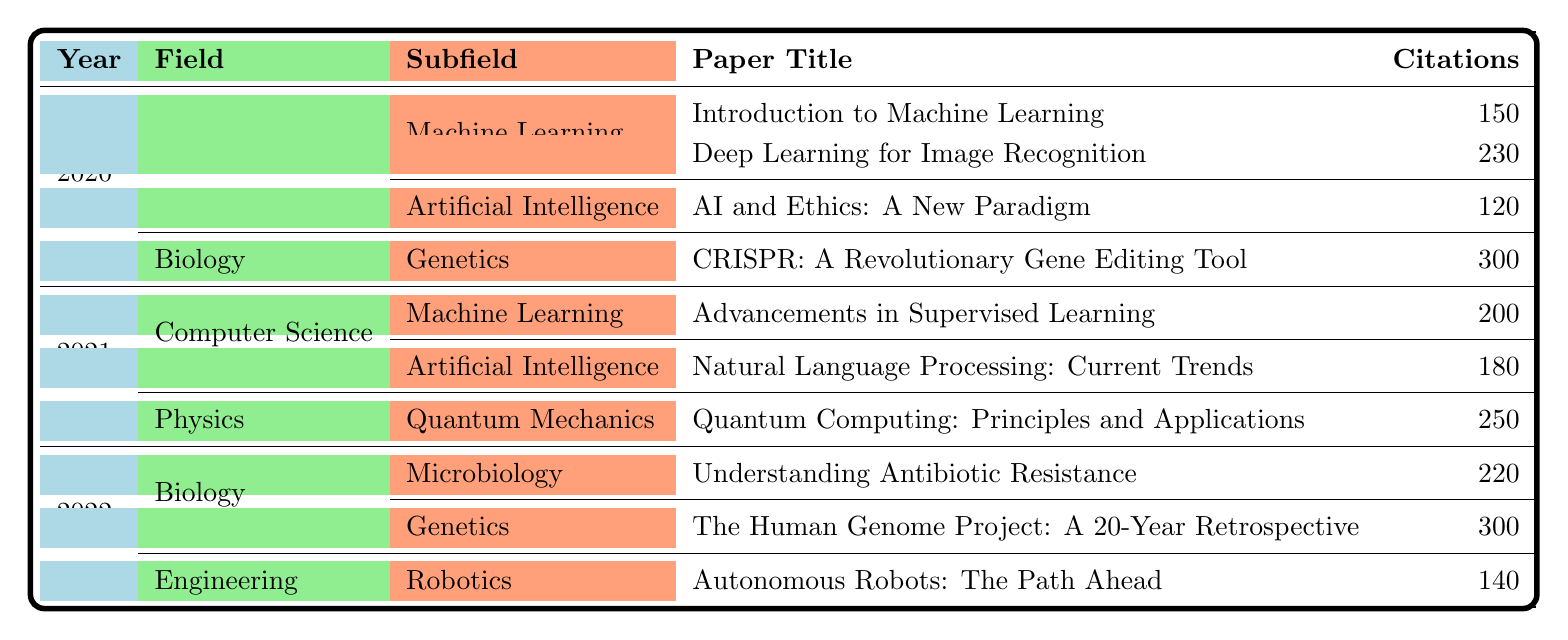What is the total number of citations for papers in Machine Learning published in 2020? In 2020, there are two papers in Machine Learning: "Introduction to Machine Learning" with 150 citations and "Deep Learning for Image Recognition" with 230 citations. Adding these citations gives 150 + 230 = 380.
Answer: 380 Which paper in Genetics received the highest number of citations in 2022? In 2022, there are two papers in Genetics: "Understanding Antibiotic Resistance" with 220 citations and "The Human Genome Project: A 20-Year Retrospective" with 300 citations. The latter has the higher citation count.
Answer: The Human Genome Project: A 20-Year Retrospective How many citations did the paper "AI and Ethics: A New Paradigm" receive? The paper "AI and Ethics: A New Paradigm," published in 2020 under Artificial Intelligence, received 120 citations as listed in the table.
Answer: 120 Is there a paper in 2021 that received more than 200 citations? In 2021, the highest number of citations recorded is for "Natural Language Processing: Current Trends" with 180 citations, and "Quantum Computing: Principles and Applications" with 250 citations. Since 250 is more than 200, there is indeed a paper that meets this criterion.
Answer: Yes What is the average number of citations for papers in Biology published across all years represented in the table? In Biology, for 2020 there is one paper with 300 citations, and in 2022, there are two papers: one with 220 citations and another with 300 citations, totaling 820 citations across 4 papers (300 + 220 + 300). Thus, the average is 820/4 = 205.
Answer: 205 Which year had the highest total number of citations in the Computer Science field? For Computer Science, in 2020 there are two papers totaling 380 citations, in 2021 one paper with 200 citations, and in 2022, there are no papers listed. Thus, the year with the highest citations is 2020 with 380 citations.
Answer: 2020 Did any papers in the Engineering field receive more citations than the highest cited paper in Biology? The highest cited paper in Biology is "CRISPR: A Revolutionary Gene Editing Tool" with 300 citations. In the Engineering field for 2022, the paper "Autonomous Robots: The Path Ahead" received only 140 citations, which is less.
Answer: No What is the difference in citations between the best and worst cited papers in 2021? In 2021, the highest citation is 250 from "Quantum Computing: Principles and Applications" and the lowest is 180 from "Natural Language Processing: Current Trends." The difference is 250 - 180 = 70 citations.
Answer: 70 